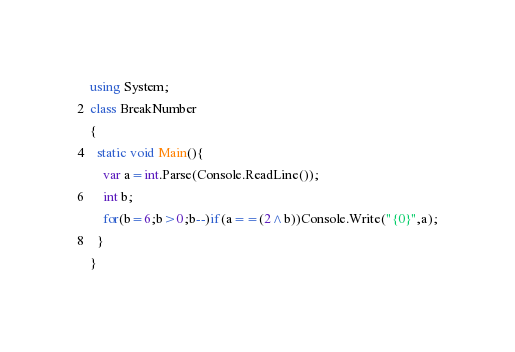Convert code to text. <code><loc_0><loc_0><loc_500><loc_500><_C#_>using System;
class BreakNumber
{
  static void Main(){
  	var a=int.Parse(Console.ReadLine());
    int b;
    for(b=6;b>0;b--)if(a==(2^b))Console.Write("{0}",a);
  }
}</code> 